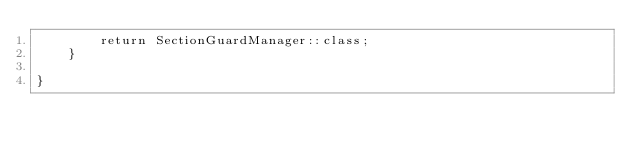<code> <loc_0><loc_0><loc_500><loc_500><_PHP_>        return SectionGuardManager::class;
    }

}</code> 